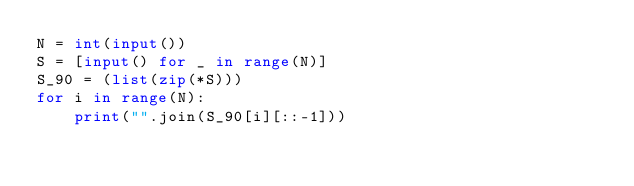Convert code to text. <code><loc_0><loc_0><loc_500><loc_500><_Python_>N = int(input())
S = [input() for _ in range(N)]
S_90 = (list(zip(*S)))
for i in range(N):
    print("".join(S_90[i][::-1]))</code> 